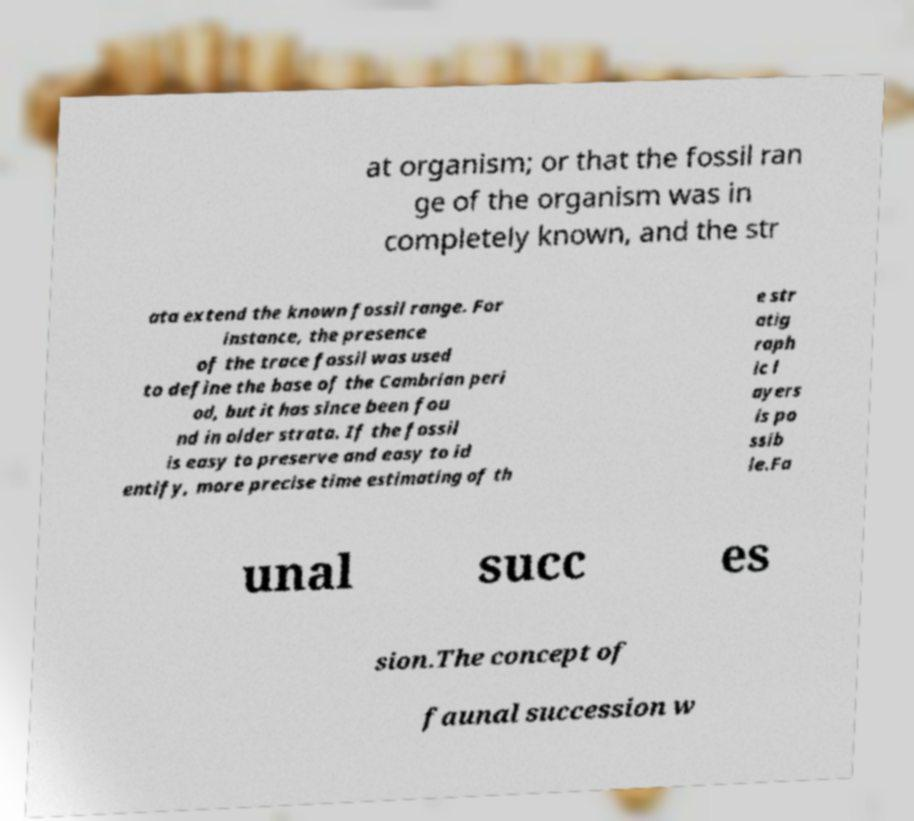Can you read and provide the text displayed in the image?This photo seems to have some interesting text. Can you extract and type it out for me? at organism; or that the fossil ran ge of the organism was in completely known, and the str ata extend the known fossil range. For instance, the presence of the trace fossil was used to define the base of the Cambrian peri od, but it has since been fou nd in older strata. If the fossil is easy to preserve and easy to id entify, more precise time estimating of th e str atig raph ic l ayers is po ssib le.Fa unal succ es sion.The concept of faunal succession w 